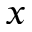Convert formula to latex. <formula><loc_0><loc_0><loc_500><loc_500>x</formula> 